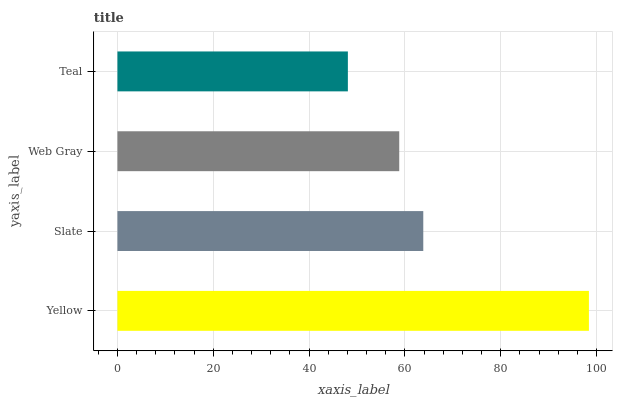Is Teal the minimum?
Answer yes or no. Yes. Is Yellow the maximum?
Answer yes or no. Yes. Is Slate the minimum?
Answer yes or no. No. Is Slate the maximum?
Answer yes or no. No. Is Yellow greater than Slate?
Answer yes or no. Yes. Is Slate less than Yellow?
Answer yes or no. Yes. Is Slate greater than Yellow?
Answer yes or no. No. Is Yellow less than Slate?
Answer yes or no. No. Is Slate the high median?
Answer yes or no. Yes. Is Web Gray the low median?
Answer yes or no. Yes. Is Teal the high median?
Answer yes or no. No. Is Yellow the low median?
Answer yes or no. No. 